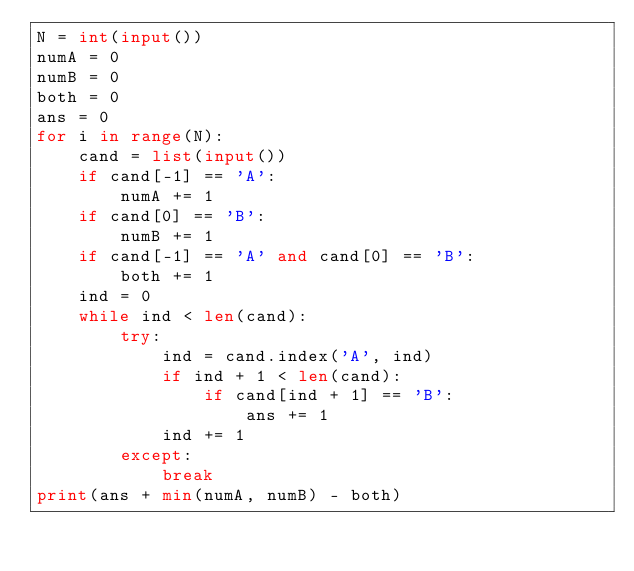<code> <loc_0><loc_0><loc_500><loc_500><_Python_>N = int(input())
numA = 0
numB = 0
both = 0
ans = 0
for i in range(N):
    cand = list(input())
    if cand[-1] == 'A':
        numA += 1
    if cand[0] == 'B':
        numB += 1
    if cand[-1] == 'A' and cand[0] == 'B':
        both += 1
    ind = 0
    while ind < len(cand):
        try:
            ind = cand.index('A', ind)
            if ind + 1 < len(cand):
                if cand[ind + 1] == 'B':
                    ans += 1
            ind += 1
        except:
            break
print(ans + min(numA, numB) - both)</code> 